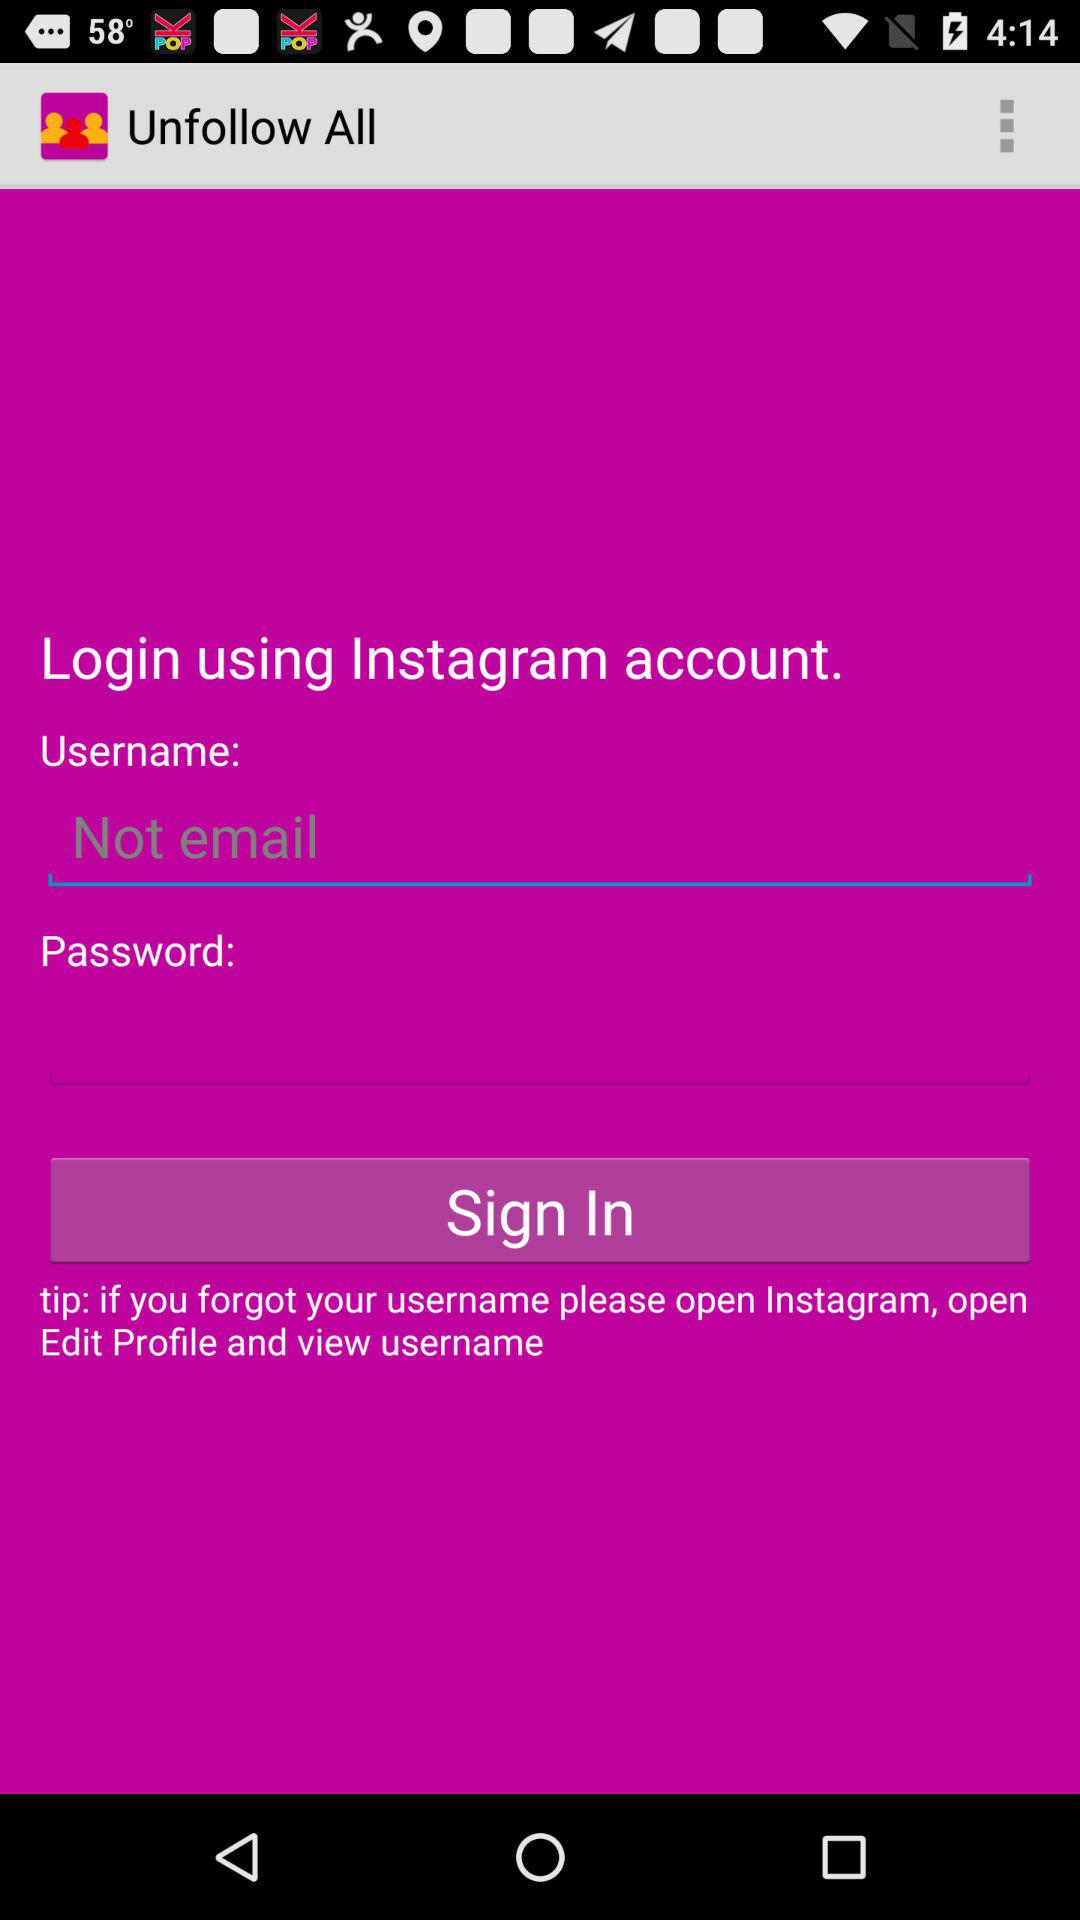What is the user name?
When the provided information is insufficient, respond with <no answer>. <no answer> 